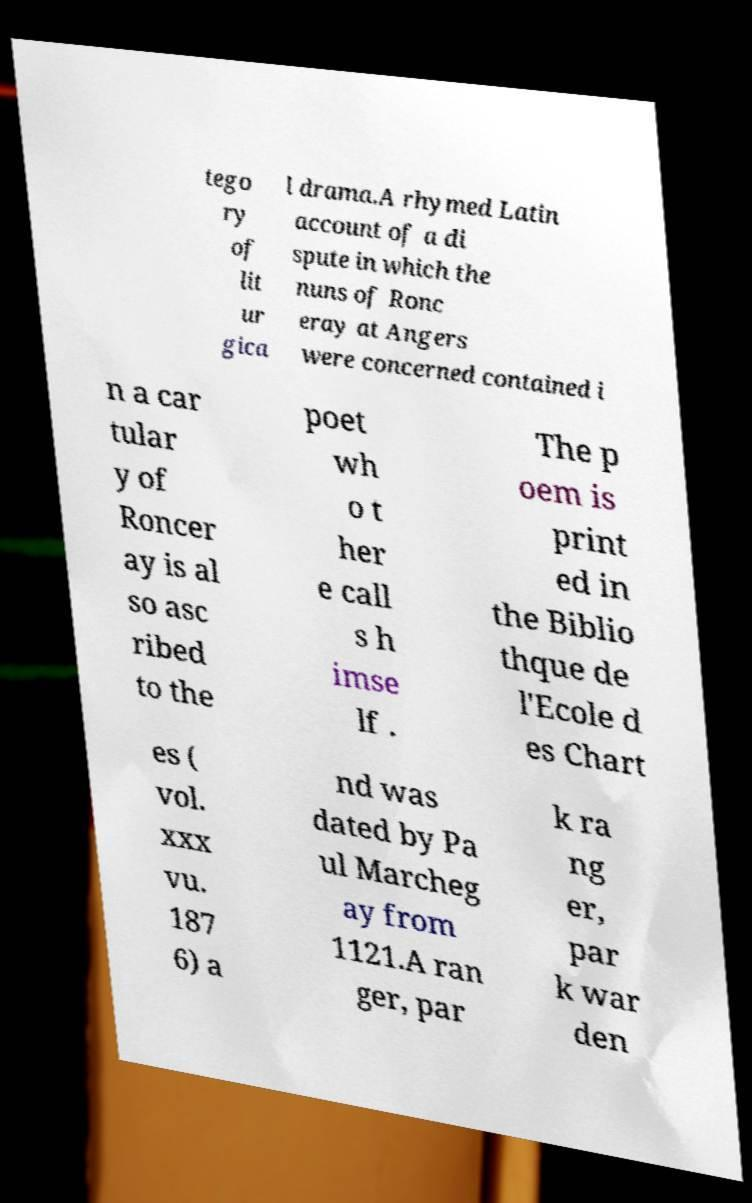Please identify and transcribe the text found in this image. tego ry of lit ur gica l drama.A rhymed Latin account of a di spute in which the nuns of Ronc eray at Angers were concerned contained i n a car tular y of Roncer ay is al so asc ribed to the poet wh o t her e call s h imse lf . The p oem is print ed in the Biblio thque de l'Ecole d es Chart es ( vol. xxx vu. 187 6) a nd was dated by Pa ul Marcheg ay from 1121.A ran ger, par k ra ng er, par k war den 